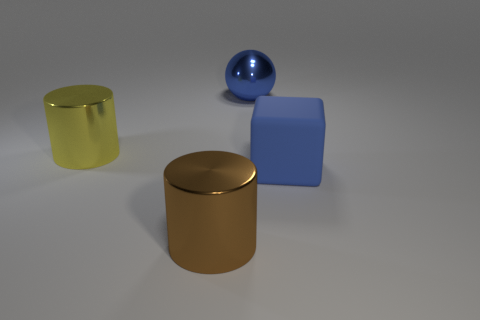Add 3 big brown blocks. How many objects exist? 7 Subtract all yellow cylinders. How many cylinders are left? 1 Subtract 0 purple balls. How many objects are left? 4 Subtract all spheres. How many objects are left? 3 Subtract 1 cubes. How many cubes are left? 0 Subtract all blue cylinders. Subtract all gray balls. How many cylinders are left? 2 Subtract all brown spheres. How many yellow cylinders are left? 1 Subtract all large rubber things. Subtract all small red shiny spheres. How many objects are left? 3 Add 2 large shiny spheres. How many large shiny spheres are left? 3 Add 3 tiny green metal objects. How many tiny green metal objects exist? 3 